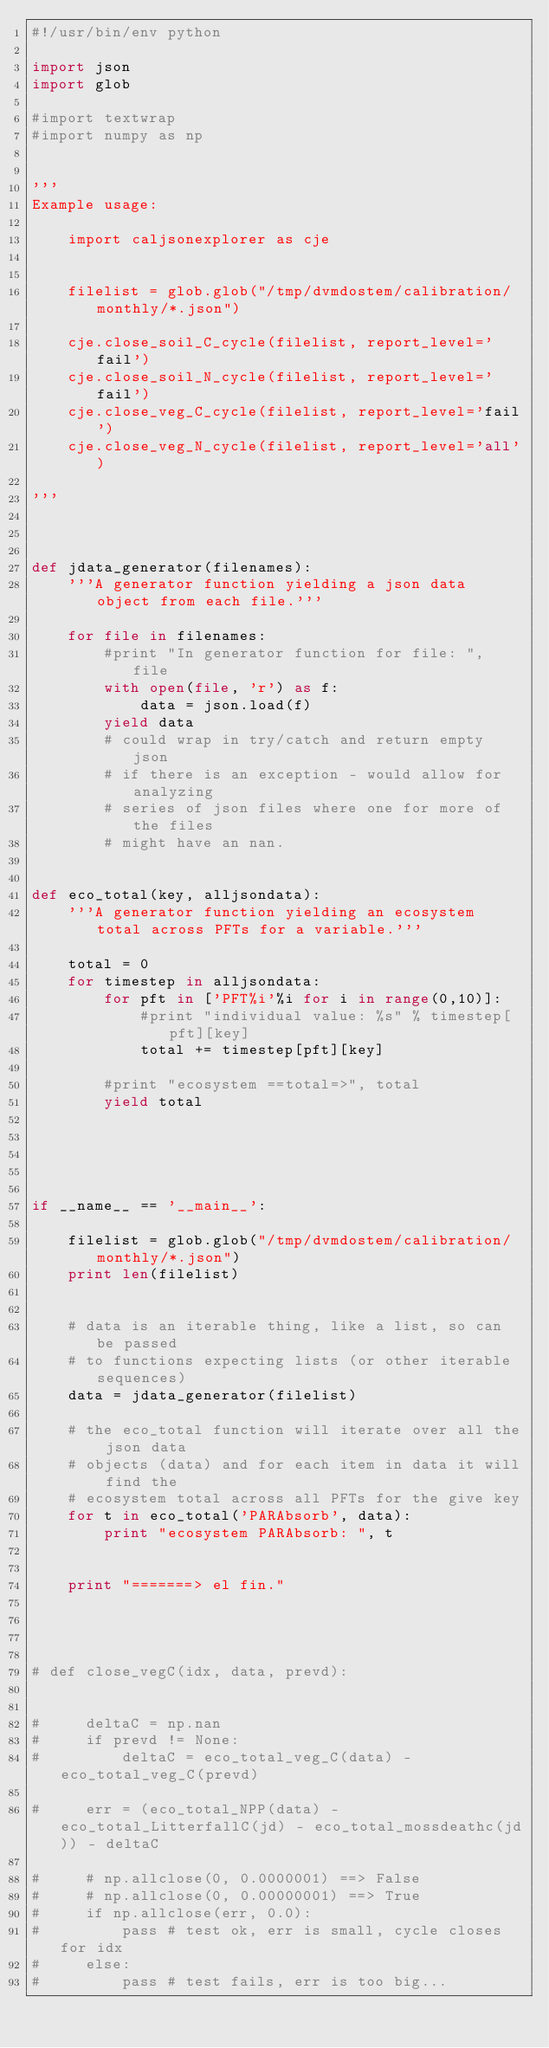Convert code to text. <code><loc_0><loc_0><loc_500><loc_500><_Python_>#!/usr/bin/env python

import json
import glob

#import textwrap
#import numpy as np


''' 
Example usage:

    import caljsonexplorer as cje


    filelist = glob.glob("/tmp/dvmdostem/calibration/monthly/*.json")

    cje.close_soil_C_cycle(filelist, report_level='fail')
    cje.close_soil_N_cycle(filelist, report_level='fail')
    cje.close_veg_C_cycle(filelist, report_level='fail')
    cje.close_veg_N_cycle(filelist, report_level='all')
    
'''



def jdata_generator(filenames):
    '''A generator function yielding a json data object from each file.'''

    for file in filenames:
        #print "In generator function for file: ", file
        with open(file, 'r') as f:
            data = json.load(f)
        yield data
        # could wrap in try/catch and return empty json
        # if there is an exception - would allow for analyzing
        # series of json files where one for more of the files
        # might have an nan.


def eco_total(key, alljsondata):
    '''A generator function yielding an ecosystem total across PFTs for a variable.'''

    total = 0
    for timestep in alljsondata:
        for pft in ['PFT%i'%i for i in range(0,10)]:
            #print "individual value: %s" % timestep[pft][key]
            total += timestep[pft][key]

        #print "ecosystem ==total=>", total
        yield total

            



if __name__ == '__main__':

    filelist = glob.glob("/tmp/dvmdostem/calibration/monthly/*.json")
    print len(filelist)


    # data is an iterable thing, like a list, so can be passed
    # to functions expecting lists (or other iterable sequences)
    data = jdata_generator(filelist)
    
    # the eco_total function will iterate over all the json data
    # objects (data) and for each item in data it will find the
    # ecosystem total across all PFTs for the give key
    for t in eco_total('PARAbsorb', data):
        print "ecosystem PARAbsorb: ", t
    

    print "=======> el fin."




# def close_vegC(idx, data, prevd):
    

#     deltaC = np.nan
#     if prevd != None:
#         deltaC = eco_total_veg_C(data) - eco_total_veg_C(prevd)

#     err = (eco_total_NPP(data) - eco_total_LitterfallC(jd) - eco_total_mossdeathc(jd)) - deltaC
    
#     # np.allclose(0, 0.0000001) ==> False
#     # np.allclose(0, 0.00000001) ==> True
#     if np.allclose(err, 0.0):
#         pass # test ok, err is small, cycle closes for idx
#     else:
#         pass # test fails, err is too big...



</code> 